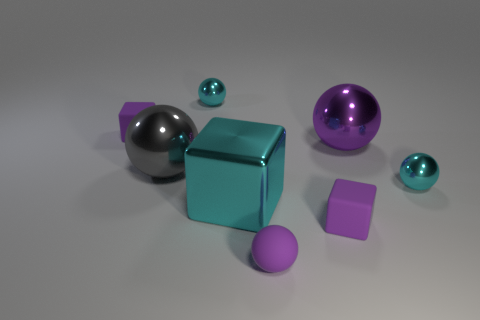Subtract all gray balls. How many balls are left? 4 Subtract all yellow balls. Subtract all purple cubes. How many balls are left? 5 Add 2 tiny cubes. How many objects exist? 10 Subtract all blocks. How many objects are left? 5 Subtract all large purple shiny balls. Subtract all cyan shiny cubes. How many objects are left? 6 Add 5 gray metallic things. How many gray metallic things are left? 6 Add 1 purple balls. How many purple balls exist? 3 Subtract 0 purple cylinders. How many objects are left? 8 